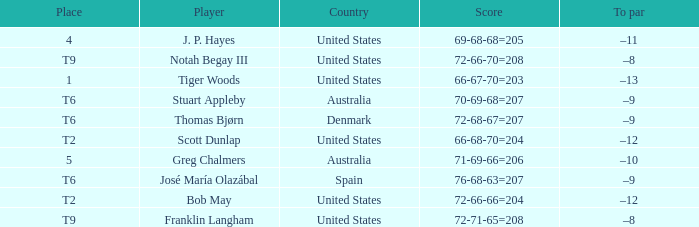What country is player thomas bjørn from? Denmark. 